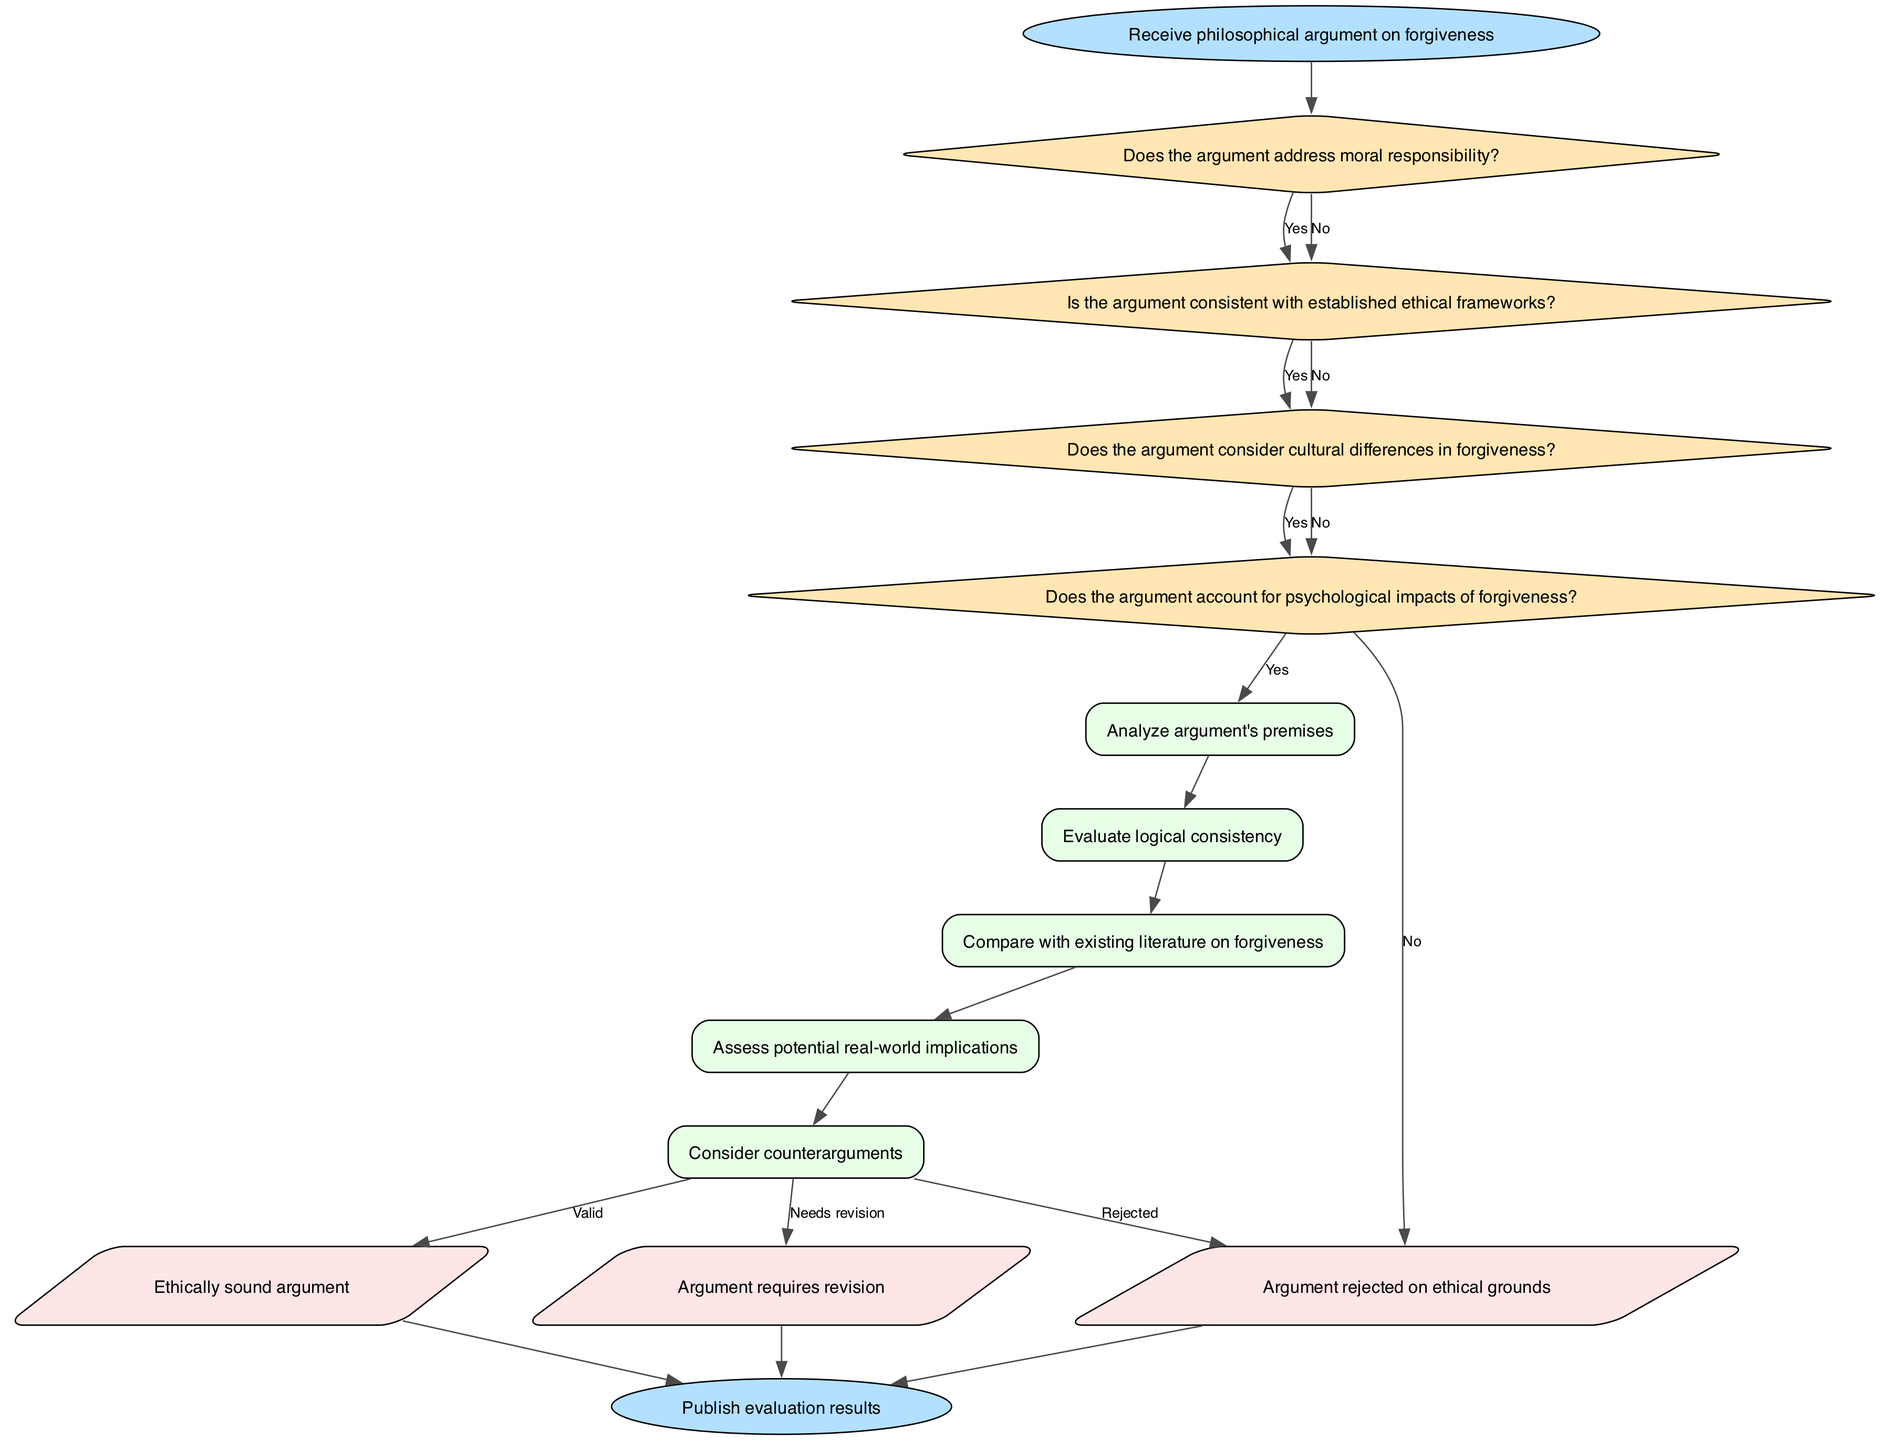What is the first node in the flowchart? The first node in the flowchart is labeled "Receive philosophical argument on forgiveness." This is indicated as the start point in the diagram.
Answer: Receive philosophical argument on forgiveness How many decision points are in the flowchart? The flowchart contains four decision points. These are the nodes that ask questions regarding the argument's moral responsibility, ethical consistency, cultural considerations, and psychological impacts.
Answer: 4 What process follows the last decision point? The process that follows the last decision point is "Assess potential real-world implications." This is the first process node reached after the fourth decision point.
Answer: Assess potential real-world implications What happens if the argument does not address moral responsibility? If the argument does not address moral responsibility, the flowchart leads to the output "Argument rejected on ethical grounds." This is indicated by the 'No' path from the first decision point, ultimately connecting to this output.
Answer: Argument rejected on ethical grounds If an argument is ethically sound, what is the output? If the argument is ethically sound, the output is "Ethically sound argument." This is reached after passing through all decision points and processes, specifically at the end of the evaluation process.
Answer: Ethically sound argument What are the shapes of the output nodes? The shapes of the output nodes are parallelograms. This is a unique feature in the flowchart that differentiates the output sections from other types of nodes (like rectangles for processes and diamonds for decisions).
Answer: Parallelogram What decision does the diagram lead to if the argument considers cultural differences in forgiveness? If the argument considers cultural differences in forgiveness, the subsequent process is to "Evaluate logical consistency." This follows the path labeled 'Yes' from the third decision point to the respective process node.
Answer: Evaluate logical consistency Which process node is the last before reaching any outputs? The last process node before reaching any outputs is "Consider counterarguments." This node is the final one in the sequence of processes handled in the flowchart.
Answer: Consider counterarguments 